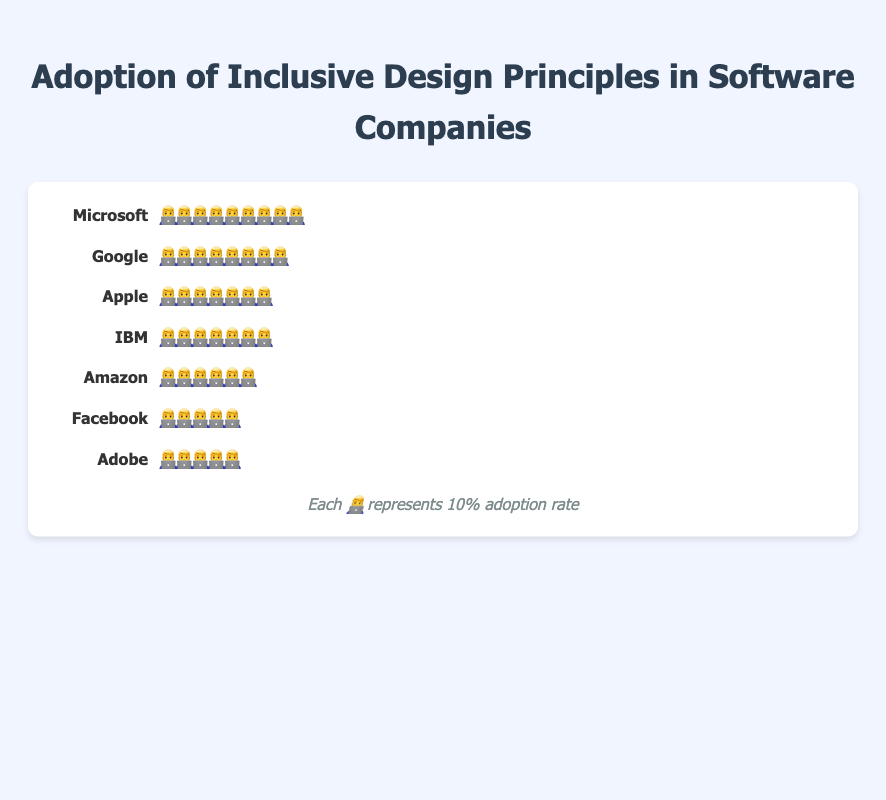Which company has the highest adoption rate of inclusive design principles? By visually examining the number of icons, Microsoft has the most icons representing a higher adoption rate.
Answer: Microsoft Which company has the lowest adoption rate of inclusive design principles? By visually examining the number of icons, Adobe has the fewest icons representing a lower adoption rate.
Answer: Adobe What does each icon represent in the chart? According to the legend at the bottom of the chart, each icon represents a 10% adoption rate.
Answer: 10% How many icons are there for Apple? By counting the number of icons next to Apple's name, we see there are 7 icons.
Answer: 7 What is the adoption rate of inclusive design principles at Google? Each icon represents 10%, and Google has 8 icons. So, 8 icons × 10% each = 80%.
Answer: 80% How does the adoption rate at IBM compare to Facebook? Count the icons for each company: IBM has 7 icons, while Facebook has 5 icons. Therefore, IBM has a higher adoption rate.
Answer: IBM's rate is higher What is the total number of icons used in the chart? Add the number of icons for all companies: 9 (Microsoft) + 8 (Google) + 7 (Apple) + 7 (IBM) + 6 (Amazon) + 5 (Facebook) + 5 (Adobe). So, the total is 47.
Answer: 47 Between which two companies is the difference in adoption rate the largest? Calculate the difference icon-wise: Microsoft (9) - Adobe (5) = 4 icons, which is the largest difference compared to others.
Answer: Microsoft and Adobe What is the average adoption rate of inclusive design principles among all companies? Sum the values for all companies and divide by the number of companies: (85 + 78 + 72 + 65 + 58 + 52 + 45) / 7. This equals 455 / 7 = 65%.
Answer: 65% How many companies have an adoption rate of 70% or higher? Count the companies with 7 or more icons: Microsoft (9), Google (8), Apple (7), IBM (7). There are 4 such companies.
Answer: 4 